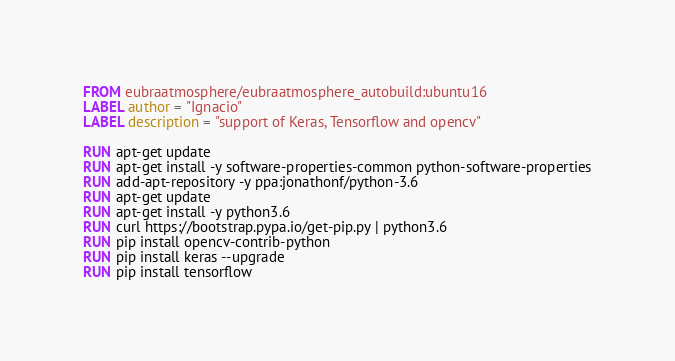<code> <loc_0><loc_0><loc_500><loc_500><_Dockerfile_>FROM eubraatmosphere/eubraatmosphere_autobuild:ubuntu16
LABEL author = "Ignacio"
LABEL description = "support of Keras, Tensorflow and opencv"
 
RUN apt-get update 
RUN apt-get install -y software-properties-common python-software-properties
RUN add-apt-repository -y ppa:jonathonf/python-3.6
RUN apt-get update
RUN apt-get install -y python3.6
RUN curl https://bootstrap.pypa.io/get-pip.py | python3.6
RUN pip install opencv-contrib-python
RUN pip install keras --upgrade
RUN pip install tensorflow

</code> 